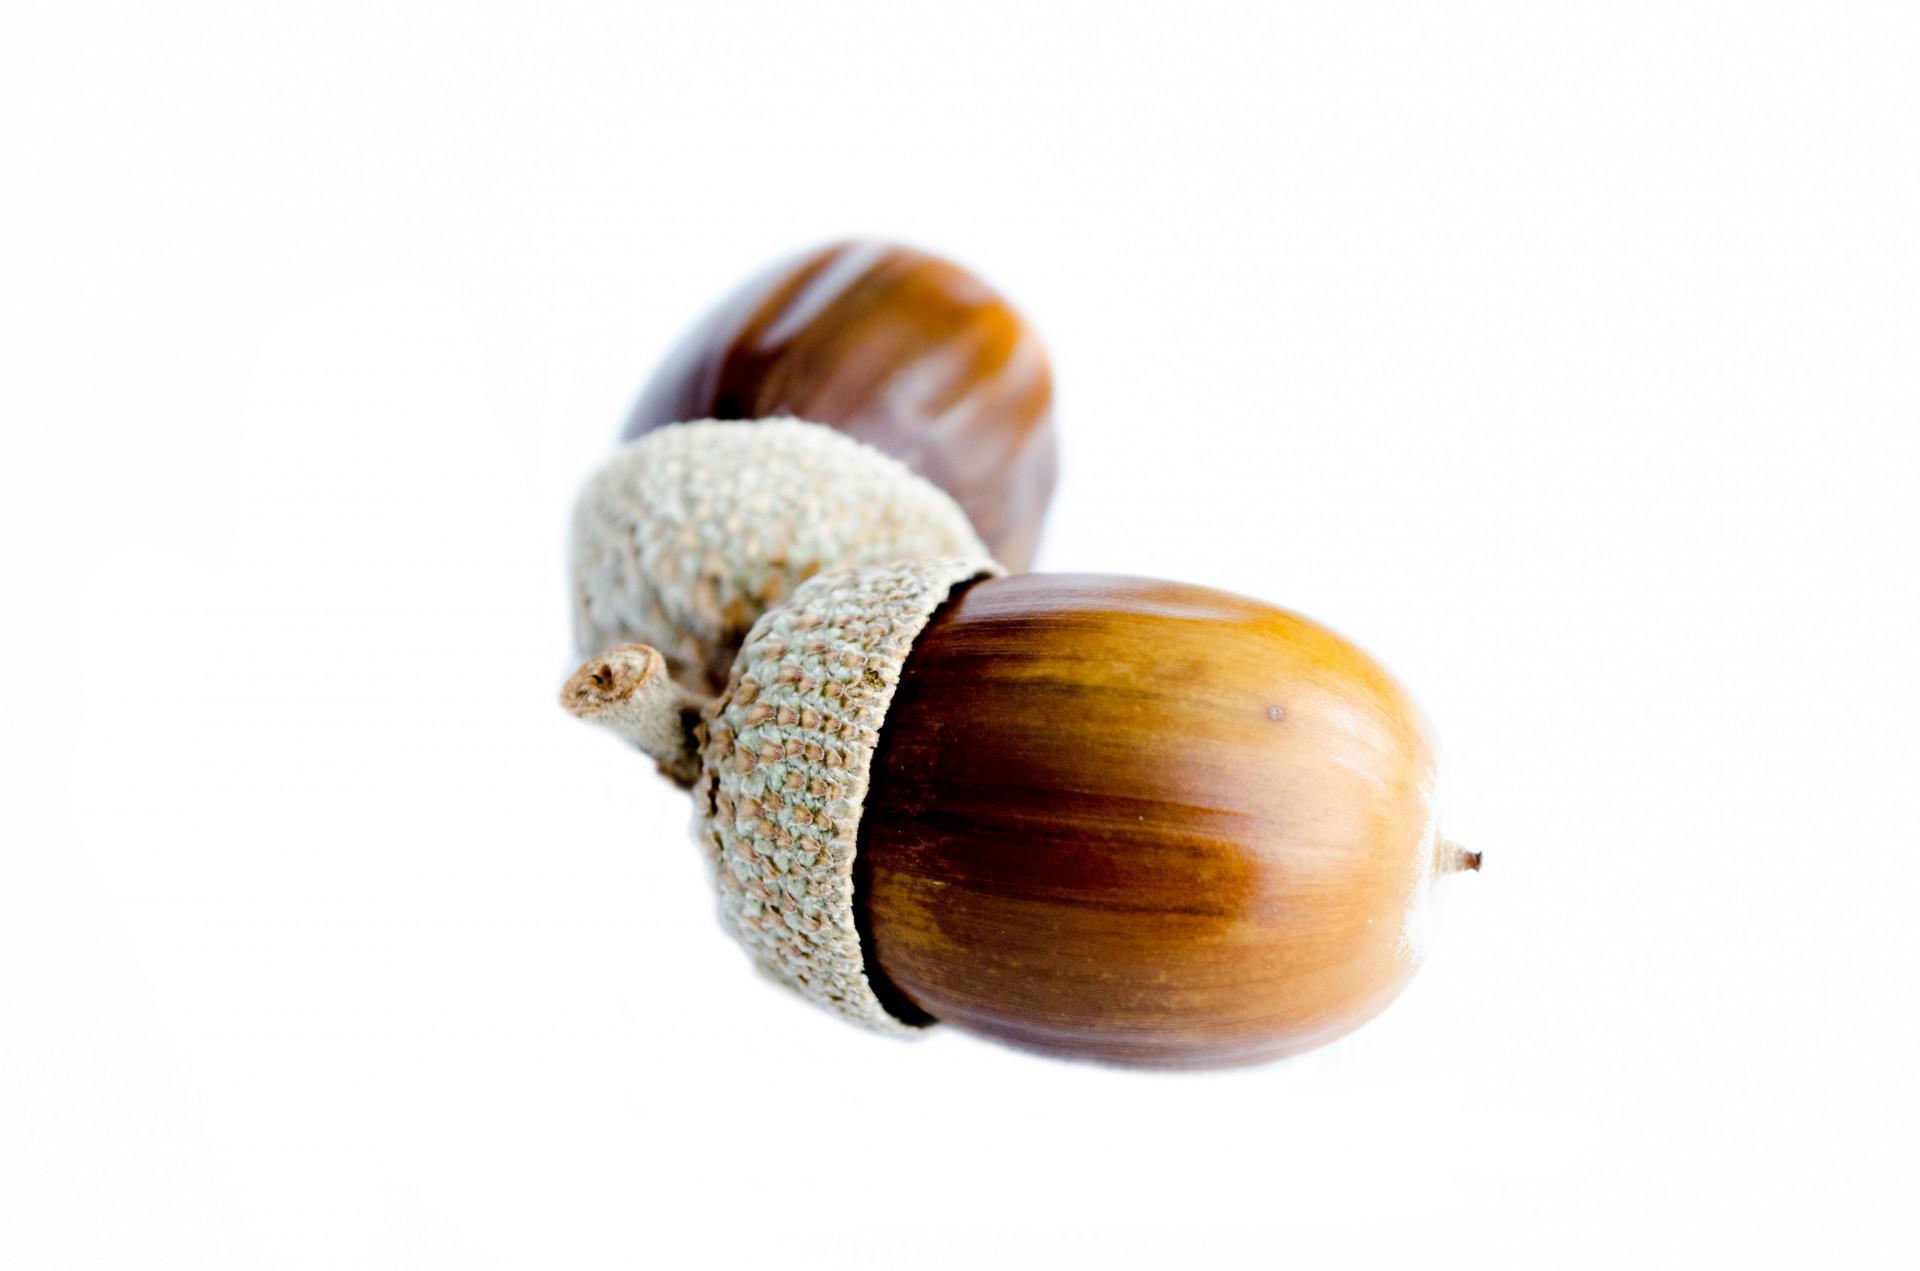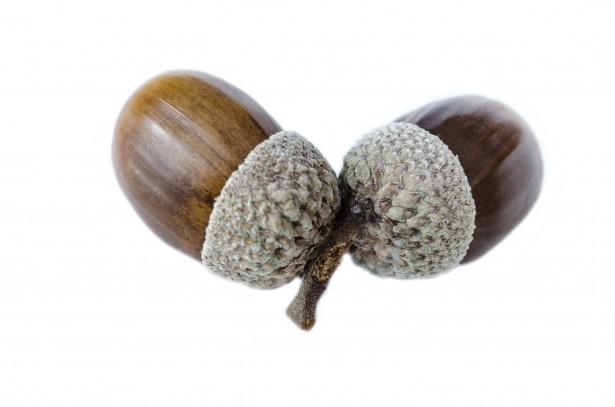The first image is the image on the left, the second image is the image on the right. Given the left and right images, does the statement "There are four acorns with brown tops." hold true? Answer yes or no. No. The first image is the image on the left, the second image is the image on the right. Assess this claim about the two images: "Each image contains one pair of acorns with their caps on, and no image contains a leaf.". Correct or not? Answer yes or no. Yes. 